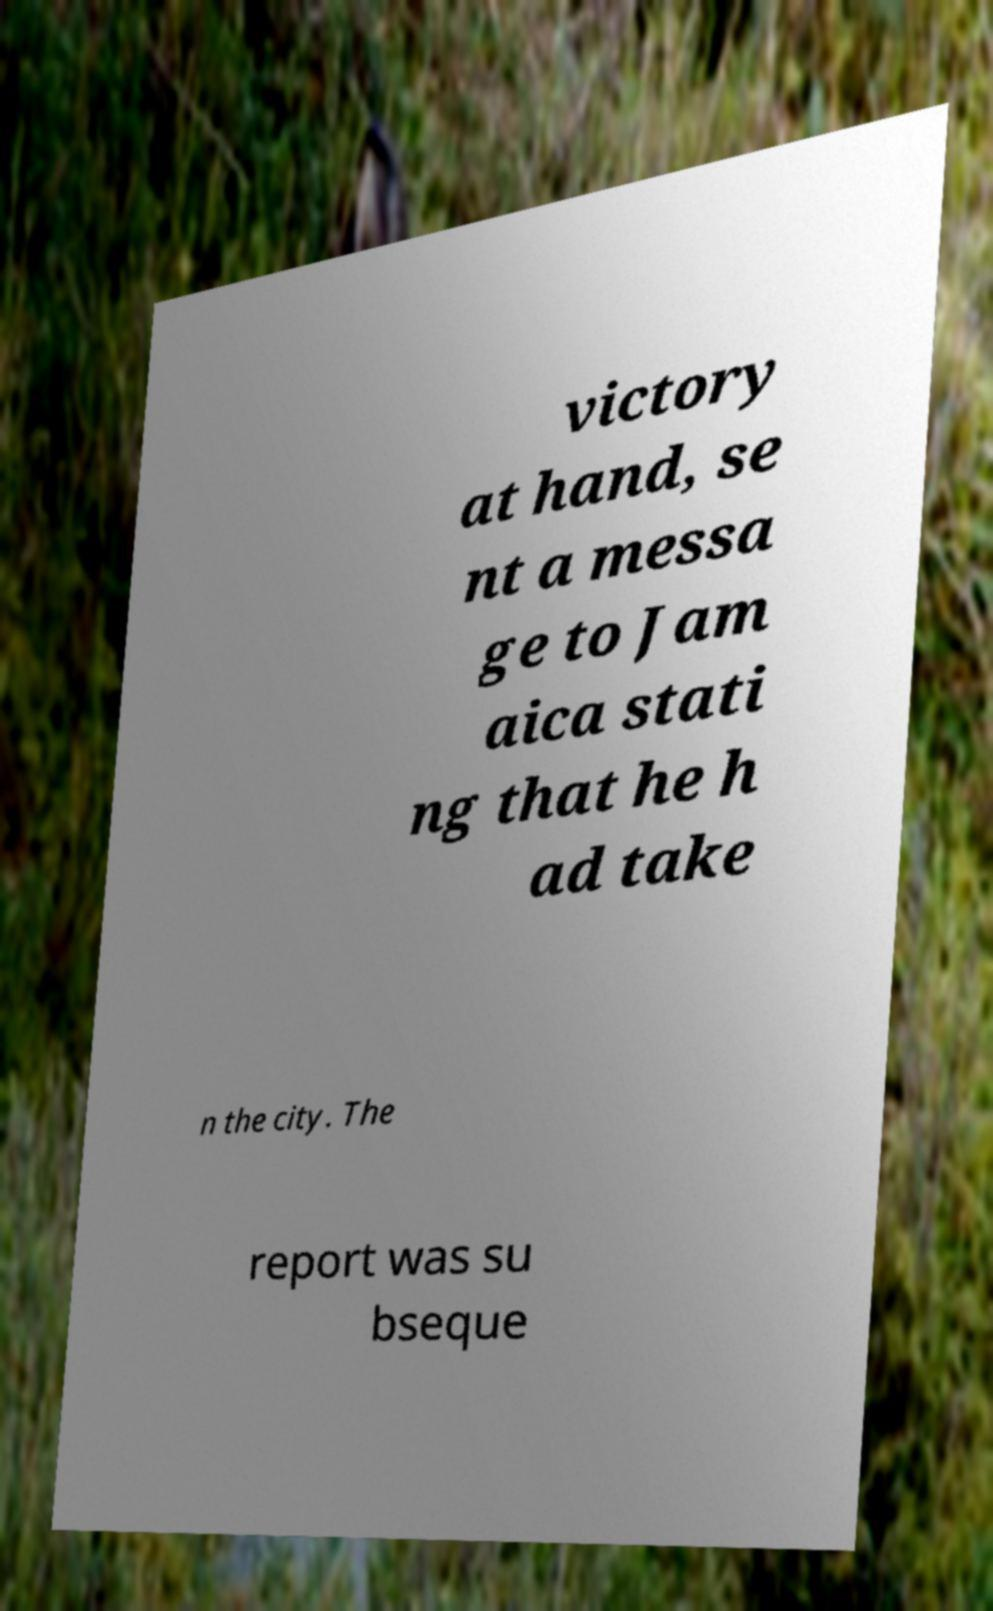What messages or text are displayed in this image? I need them in a readable, typed format. victory at hand, se nt a messa ge to Jam aica stati ng that he h ad take n the city. The report was su bseque 